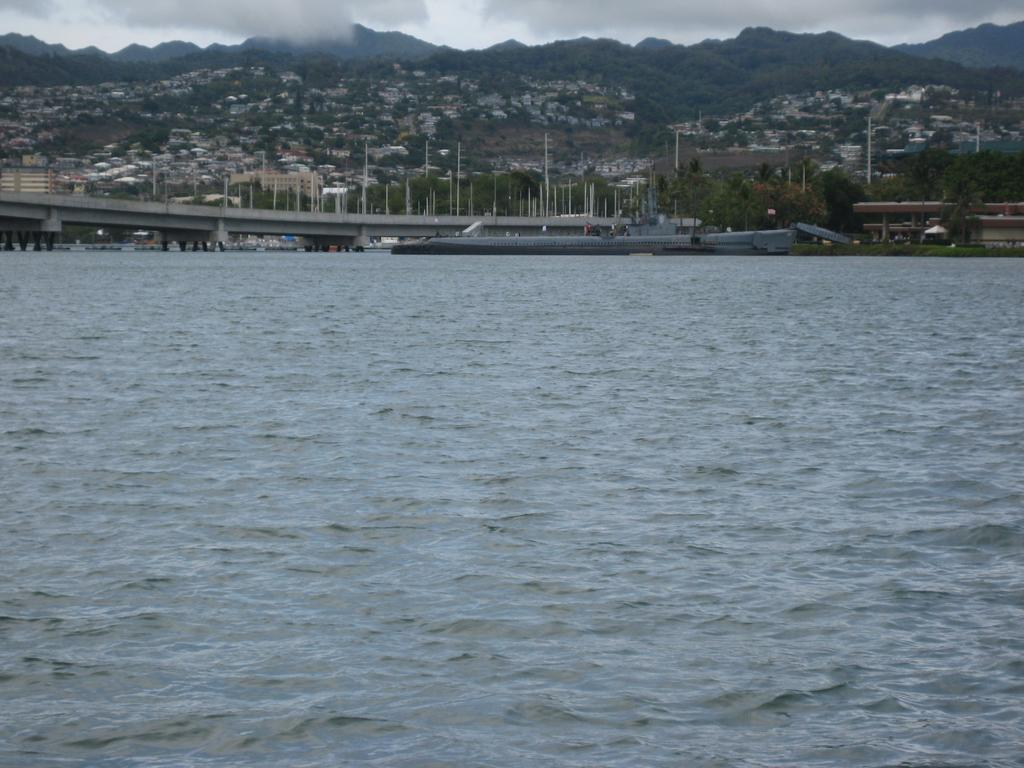What is visible in the image? Water is visible in the image. What structures can be seen in the background of the image? There is a bridge, many poles, trees, buildings, and mountains visible in the background of the image. What natural elements are present in the image? Clouds and the sky are visible in the image. How many dolls are playing on the team in the image? There are no dolls or teams present in the image. Where are the kittens playing in the image? There are no kittens present in the image. 